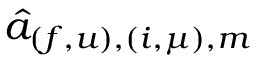Convert formula to latex. <formula><loc_0><loc_0><loc_500><loc_500>\hat { a } _ { ( f , u ) , ( i , \mu ) , m }</formula> 